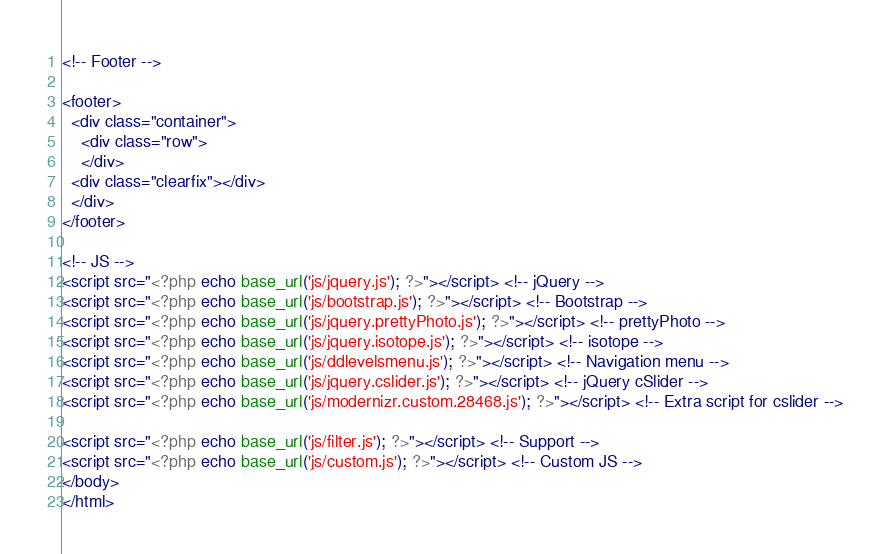Convert code to text. <code><loc_0><loc_0><loc_500><loc_500><_PHP_><!-- Footer -->

<footer>
  <div class="container">
    <div class="row">
    </div>    
  <div class="clearfix"></div>
  </div>  
</footer>

<!-- JS -->
<script src="<?php echo base_url('js/jquery.js'); ?>"></script> <!-- jQuery -->
<script src="<?php echo base_url('js/bootstrap.js'); ?>"></script> <!-- Bootstrap -->
<script src="<?php echo base_url('js/jquery.prettyPhoto.js'); ?>"></script> <!-- prettyPhoto -->
<script src="<?php echo base_url('js/jquery.isotope.js'); ?>"></script> <!-- isotope -->
<script src="<?php echo base_url('js/ddlevelsmenu.js'); ?>"></script> <!-- Navigation menu -->
<script src="<?php echo base_url('js/jquery.cslider.js'); ?>"></script> <!-- jQuery cSlider -->
<script src="<?php echo base_url('js/modernizr.custom.28468.js'); ?>"></script> <!-- Extra script for cslider -->

<script src="<?php echo base_url('js/filter.js'); ?>"></script> <!-- Support -->
<script src="<?php echo base_url('js/custom.js'); ?>"></script> <!-- Custom JS -->
</body>
</html></code> 